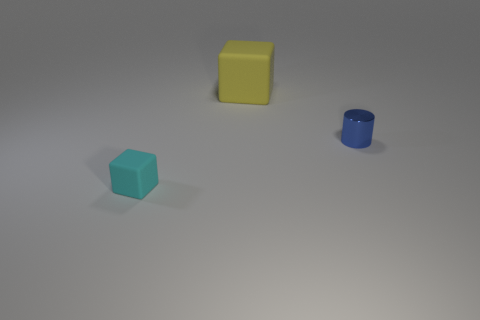Add 1 small gray metallic objects. How many objects exist? 4 Subtract all blocks. How many objects are left? 1 Add 2 blocks. How many blocks exist? 4 Subtract 0 yellow spheres. How many objects are left? 3 Subtract all small blue shiny cylinders. Subtract all small matte objects. How many objects are left? 1 Add 1 small cubes. How many small cubes are left? 2 